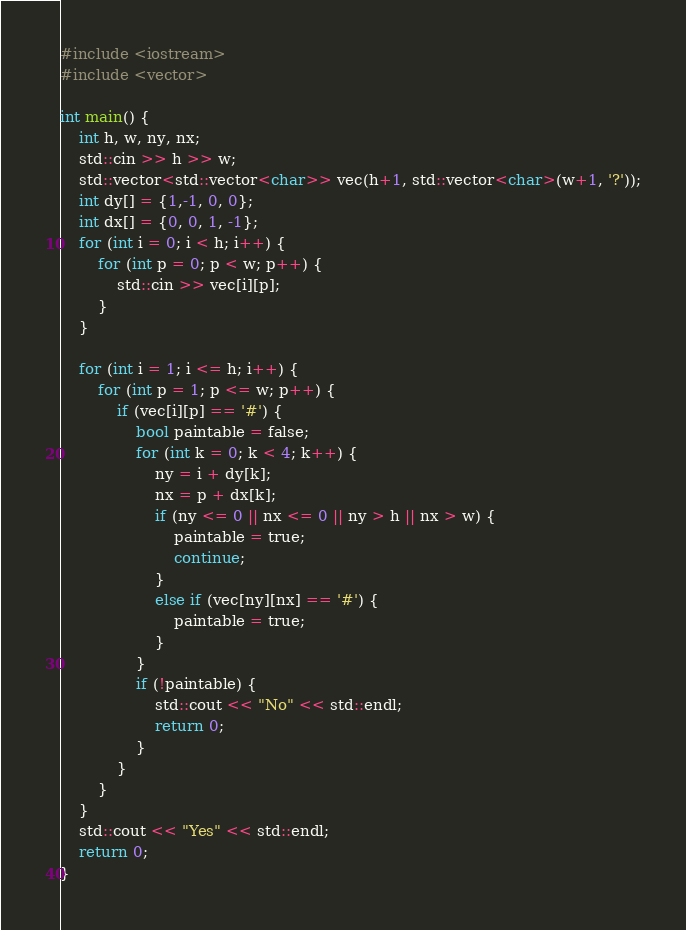Convert code to text. <code><loc_0><loc_0><loc_500><loc_500><_C++_>#include <iostream>
#include <vector>

int main() {
    int h, w, ny, nx;
    std::cin >> h >> w;
    std::vector<std::vector<char>> vec(h+1, std::vector<char>(w+1, '?'));
    int dy[] = {1,-1, 0, 0};
    int dx[] = {0, 0, 1, -1};
    for (int i = 0; i < h; i++) {
        for (int p = 0; p < w; p++) {
            std::cin >> vec[i][p];
        }
    }

    for (int i = 1; i <= h; i++) {
        for (int p = 1; p <= w; p++) {
            if (vec[i][p] == '#') {
                bool paintable = false;
                for (int k = 0; k < 4; k++) {
                    ny = i + dy[k];
                    nx = p + dx[k];
                    if (ny <= 0 || nx <= 0 || ny > h || nx > w) {
                        paintable = true;
                        continue;
                    }
                    else if (vec[ny][nx] == '#') {
                        paintable = true;
                    }
                }
                if (!paintable) {
                    std::cout << "No" << std::endl;
                    return 0;
                }
            }
        }
    }
    std::cout << "Yes" << std::endl;
    return 0;
}
</code> 